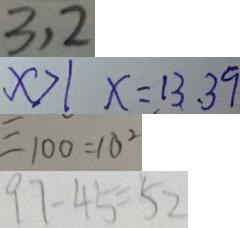Convert formula to latex. <formula><loc_0><loc_0><loc_500><loc_500>3 , 2 
 x > 1 x = 1 3 , 3 9 
 = 1 0 0 = 1 0 ^ { 2 } 
 9 7 - 4 5 = 5 2</formula> 